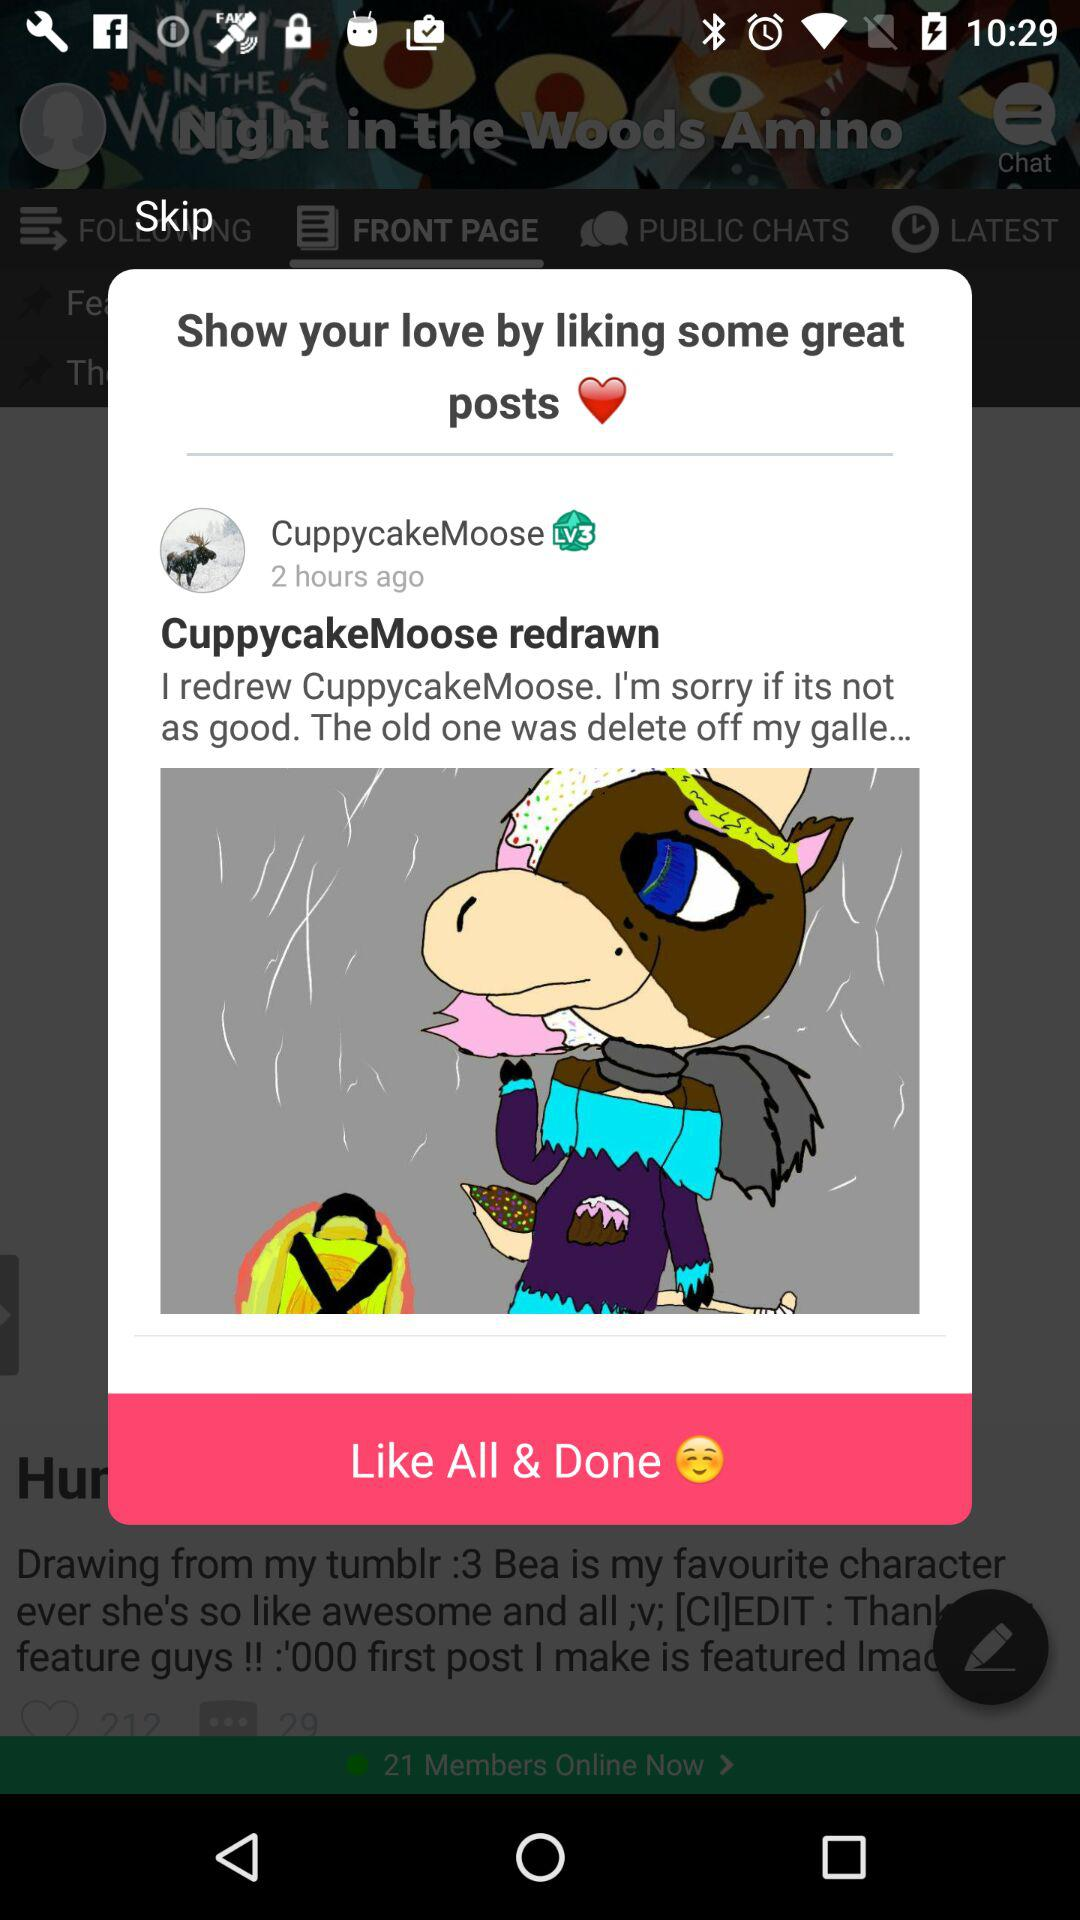How long ago was the blog posted? The blog was posted 2 hours ago. 